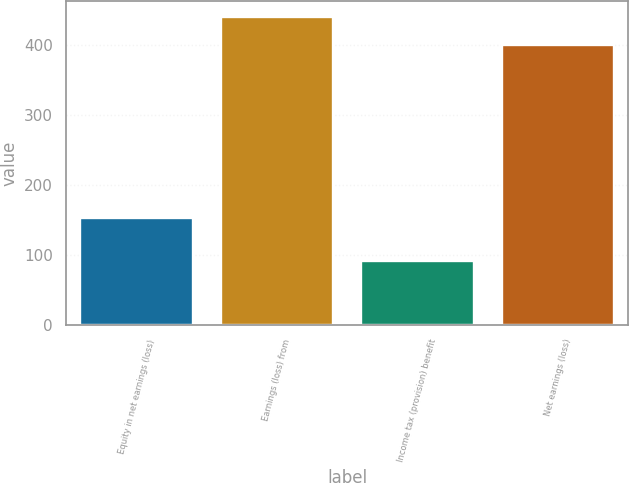Convert chart. <chart><loc_0><loc_0><loc_500><loc_500><bar_chart><fcel>Equity in net earnings (loss)<fcel>Earnings (loss) from<fcel>Income tax (provision) benefit<fcel>Net earnings (loss)<nl><fcel>153<fcel>440.4<fcel>91<fcel>399.7<nl></chart> 